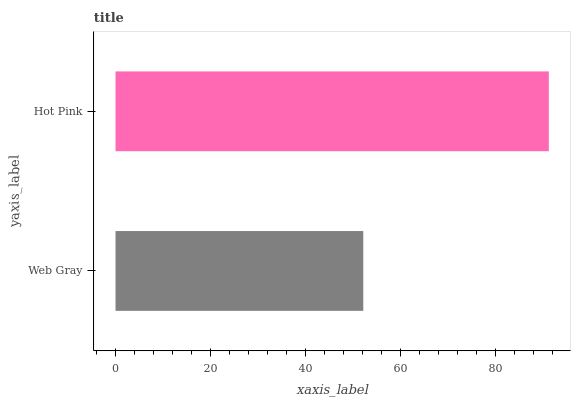Is Web Gray the minimum?
Answer yes or no. Yes. Is Hot Pink the maximum?
Answer yes or no. Yes. Is Hot Pink the minimum?
Answer yes or no. No. Is Hot Pink greater than Web Gray?
Answer yes or no. Yes. Is Web Gray less than Hot Pink?
Answer yes or no. Yes. Is Web Gray greater than Hot Pink?
Answer yes or no. No. Is Hot Pink less than Web Gray?
Answer yes or no. No. Is Hot Pink the high median?
Answer yes or no. Yes. Is Web Gray the low median?
Answer yes or no. Yes. Is Web Gray the high median?
Answer yes or no. No. Is Hot Pink the low median?
Answer yes or no. No. 